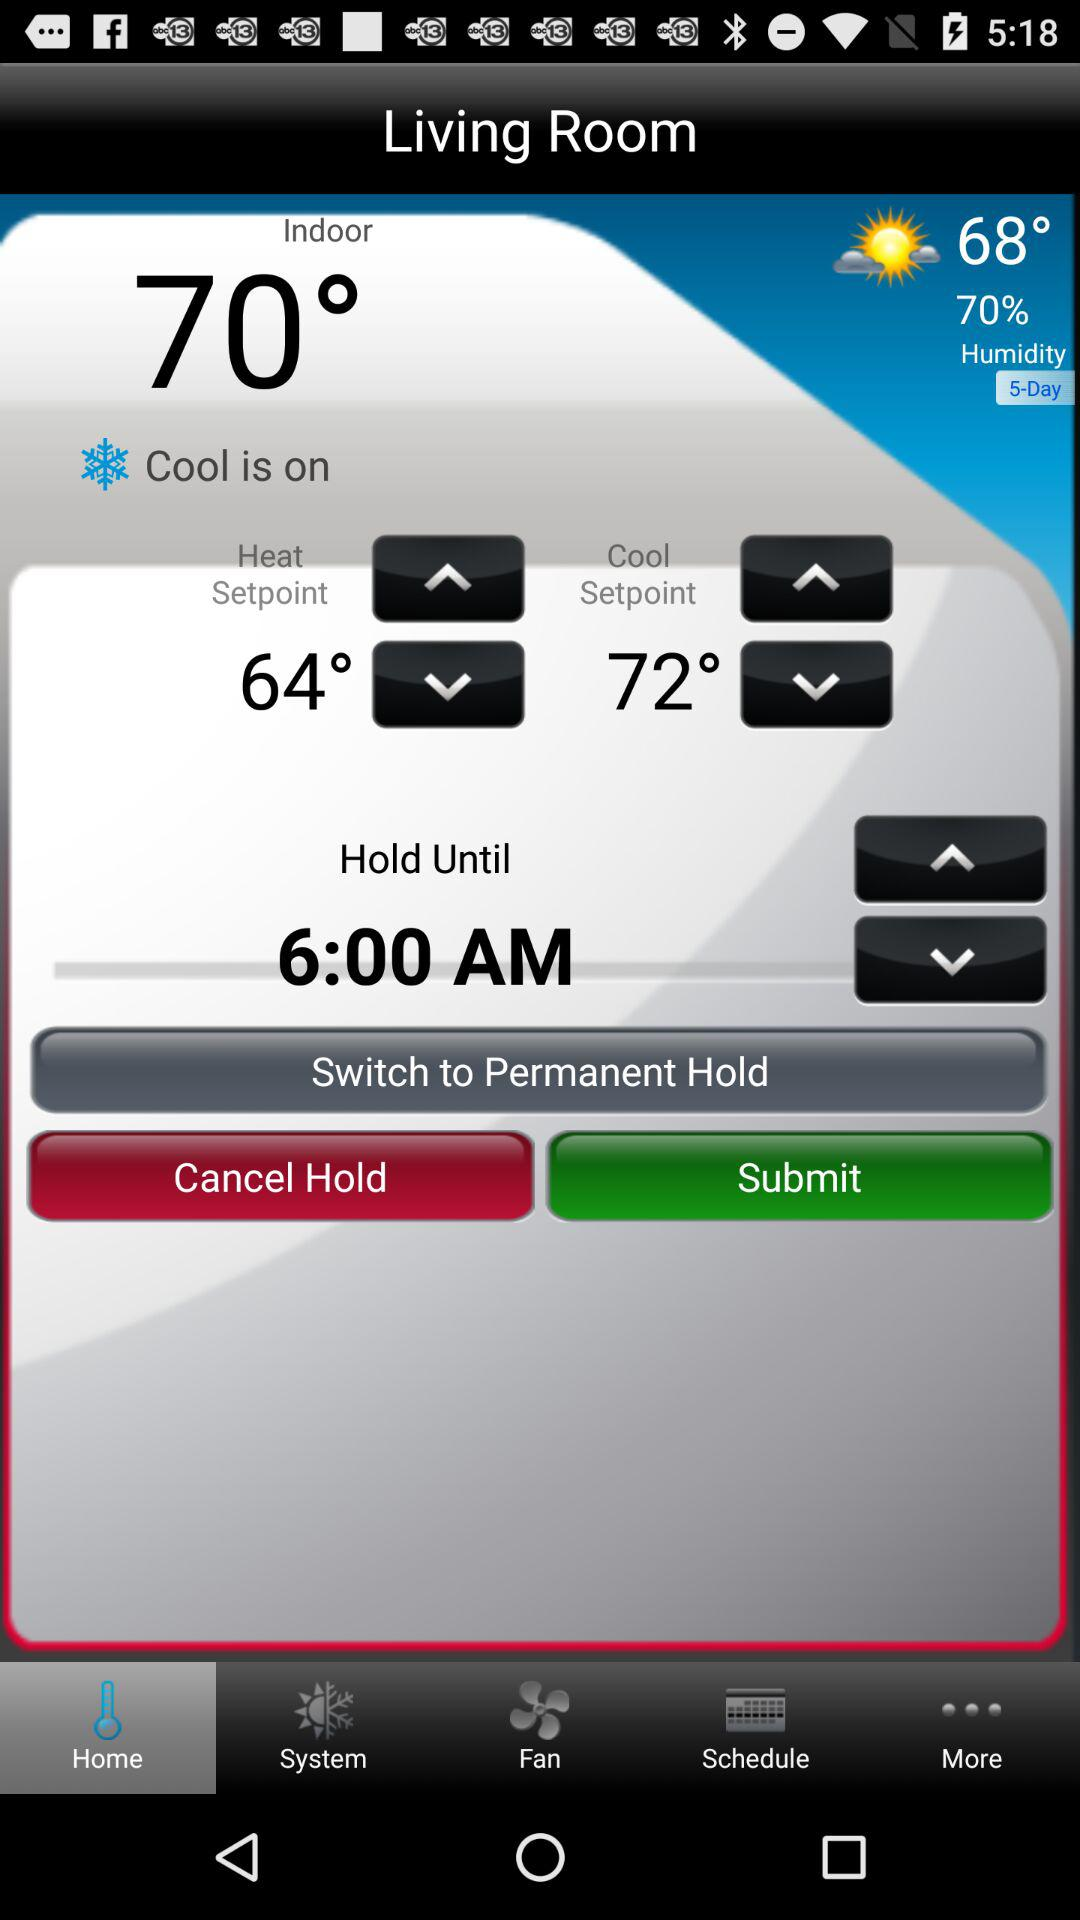What is the indoor temperature? The indoor temperature is 70°. 